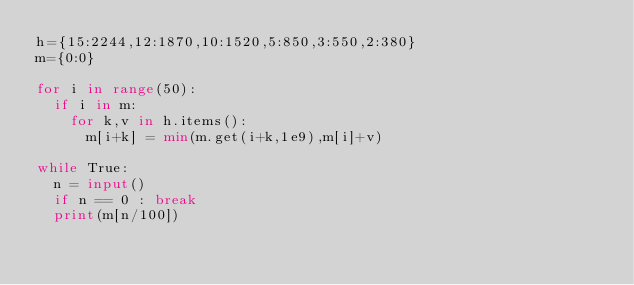<code> <loc_0><loc_0><loc_500><loc_500><_Python_>h={15:2244,12:1870,10:1520,5:850,3:550,2:380}
m={0:0}

for i in range(50):
  if i in m:
    for k,v in h.items():
      m[i+k] = min(m.get(i+k,1e9),m[i]+v)

while True:
  n = input()
  if n == 0 : break
  print(m[n/100])</code> 